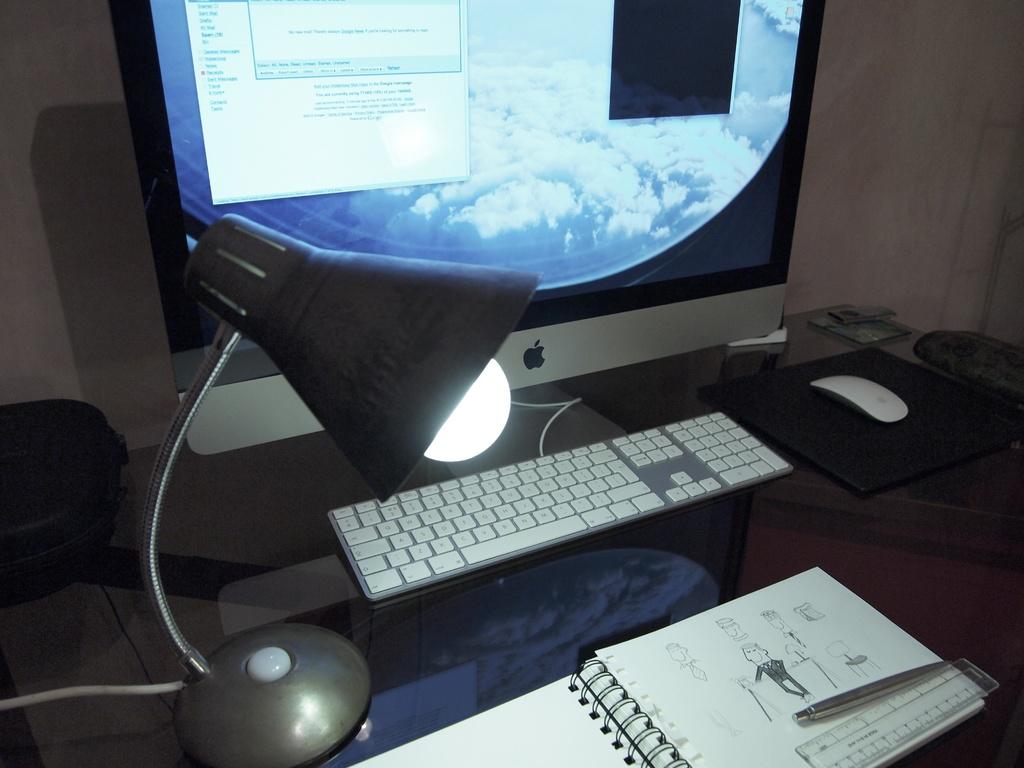What brand is the computer?
Your answer should be compact. Apple. 